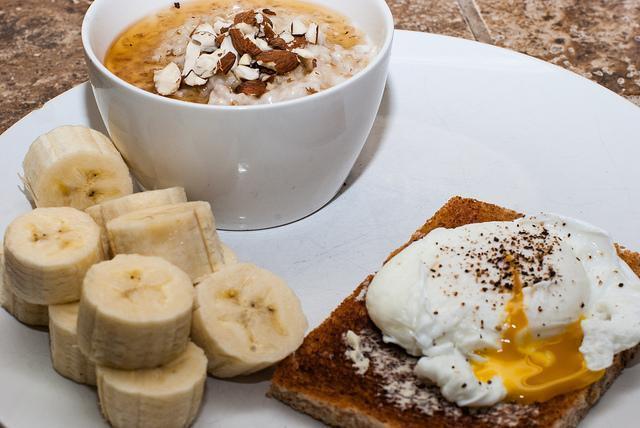What is this style of egg called?
Choose the right answer from the provided options to respond to the question.
Options: Soft boiled, scrambled, hard boiled, poached. Poached. 